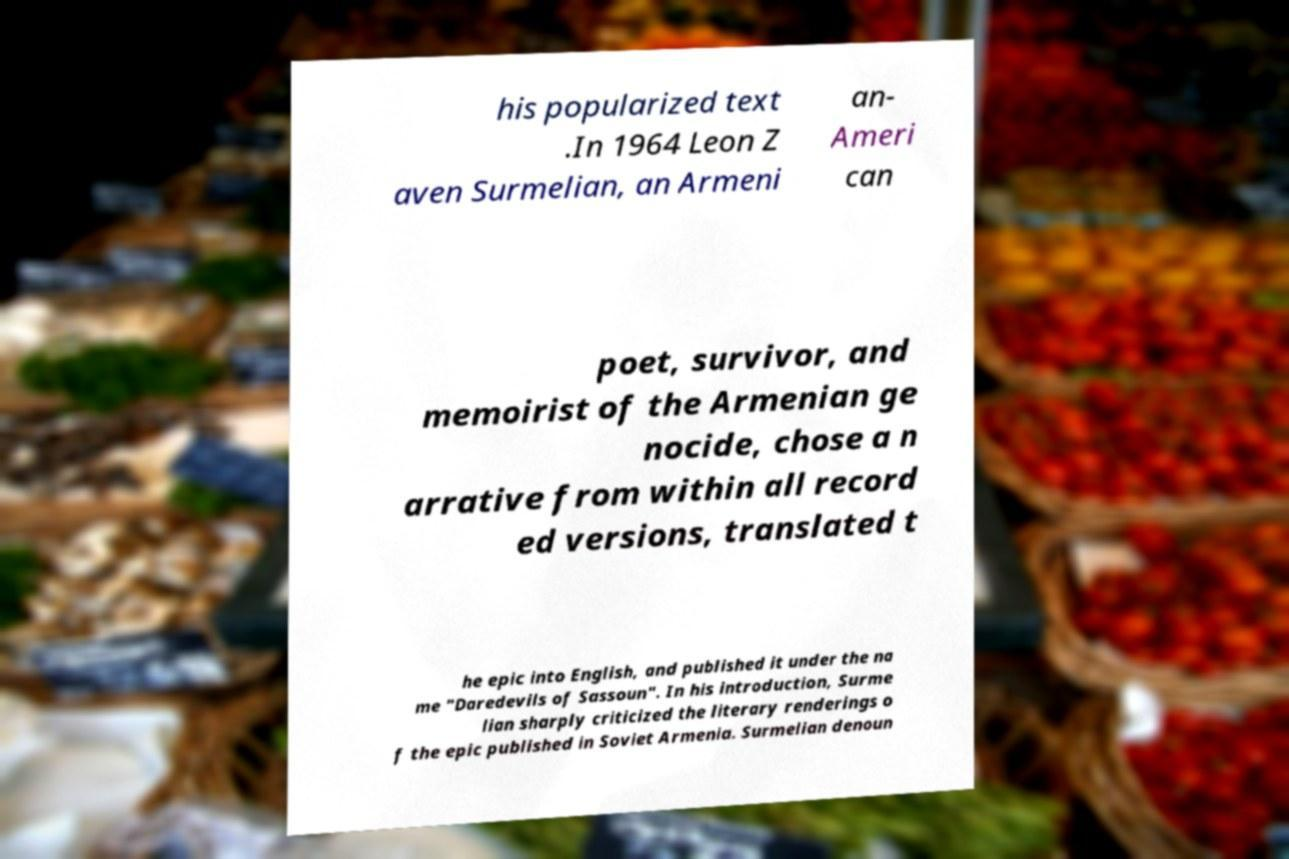Could you extract and type out the text from this image? his popularized text .In 1964 Leon Z aven Surmelian, an Armeni an- Ameri can poet, survivor, and memoirist of the Armenian ge nocide, chose a n arrative from within all record ed versions, translated t he epic into English, and published it under the na me "Daredevils of Sassoun". In his introduction, Surme lian sharply criticized the literary renderings o f the epic published in Soviet Armenia. Surmelian denoun 